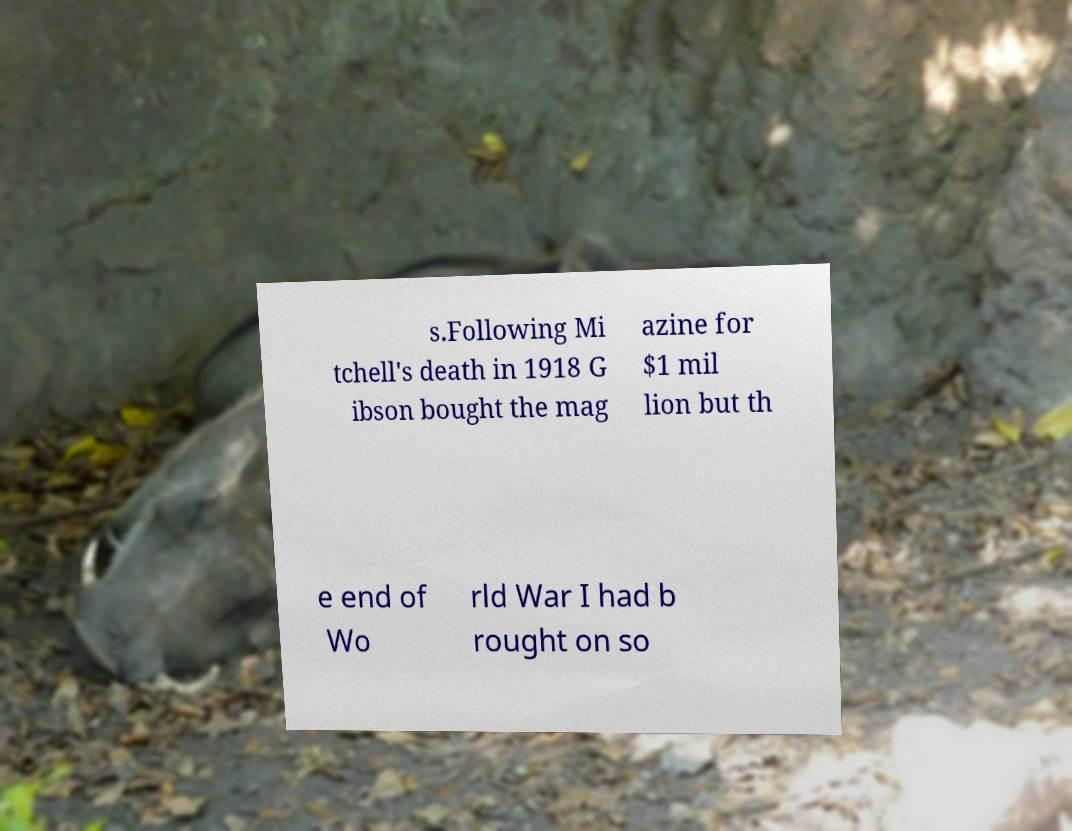For documentation purposes, I need the text within this image transcribed. Could you provide that? s.Following Mi tchell's death in 1918 G ibson bought the mag azine for $1 mil lion but th e end of Wo rld War I had b rought on so 